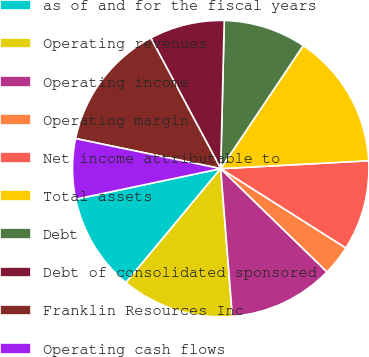Convert chart to OTSL. <chart><loc_0><loc_0><loc_500><loc_500><pie_chart><fcel>as of and for the fiscal years<fcel>Operating revenues<fcel>Operating income<fcel>Operating margin<fcel>Net income attributable to<fcel>Total assets<fcel>Debt<fcel>Debt of consolidated sponsored<fcel>Franklin Resources Inc<fcel>Operating cash flows<nl><fcel>10.66%<fcel>12.29%<fcel>11.48%<fcel>3.28%<fcel>9.84%<fcel>14.75%<fcel>9.02%<fcel>8.2%<fcel>13.93%<fcel>6.56%<nl></chart> 